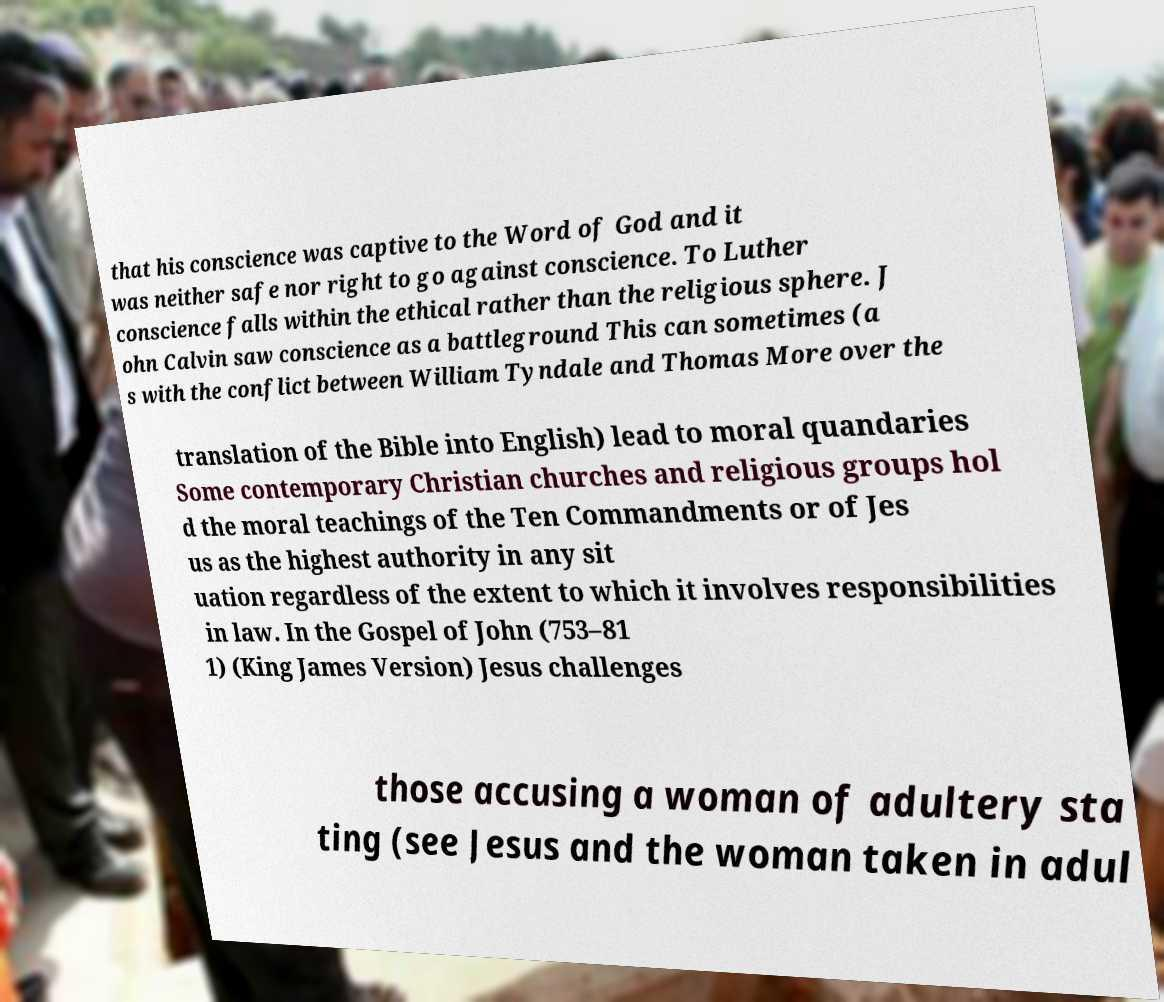I need the written content from this picture converted into text. Can you do that? that his conscience was captive to the Word of God and it was neither safe nor right to go against conscience. To Luther conscience falls within the ethical rather than the religious sphere. J ohn Calvin saw conscience as a battleground This can sometimes (a s with the conflict between William Tyndale and Thomas More over the translation of the Bible into English) lead to moral quandaries Some contemporary Christian churches and religious groups hol d the moral teachings of the Ten Commandments or of Jes us as the highest authority in any sit uation regardless of the extent to which it involves responsibilities in law. In the Gospel of John (753–81 1) (King James Version) Jesus challenges those accusing a woman of adultery sta ting (see Jesus and the woman taken in adul 